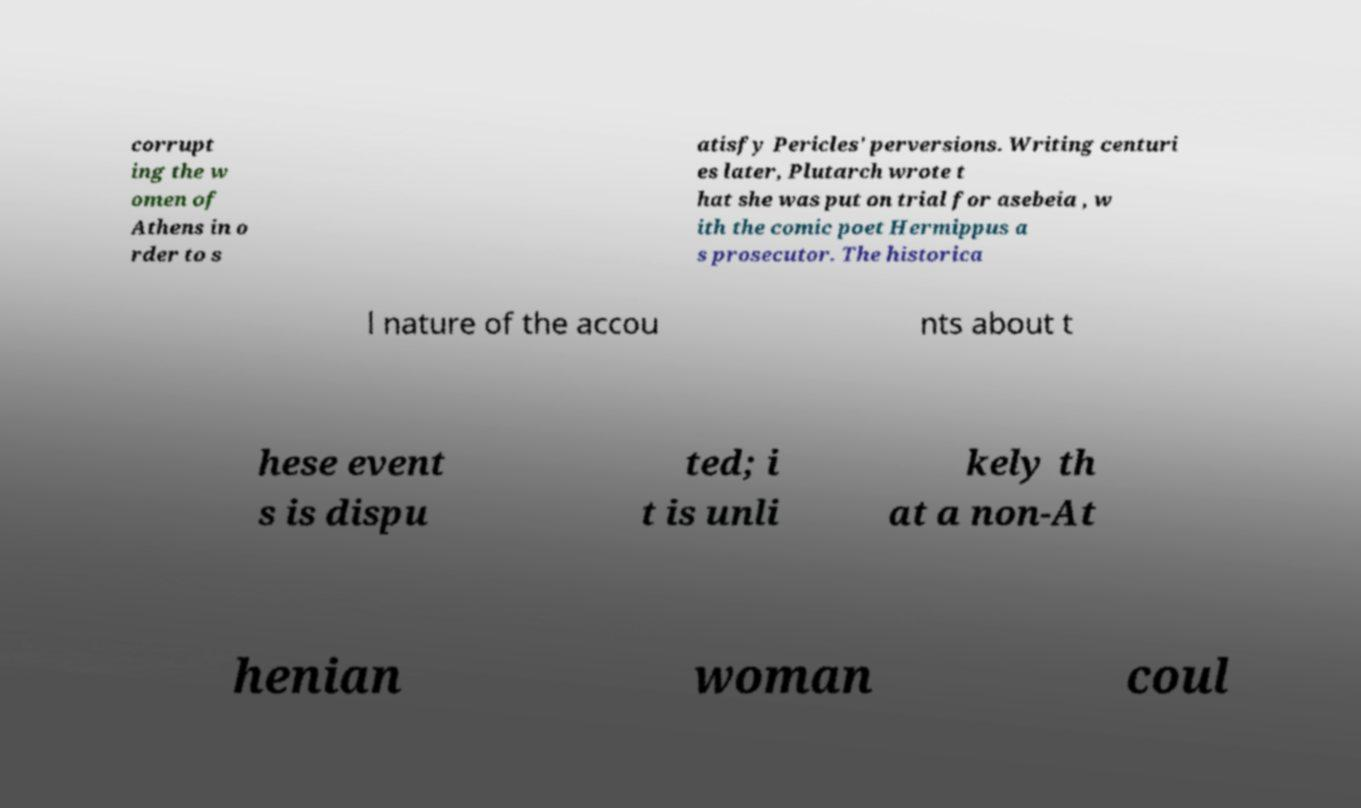I need the written content from this picture converted into text. Can you do that? corrupt ing the w omen of Athens in o rder to s atisfy Pericles' perversions. Writing centuri es later, Plutarch wrote t hat she was put on trial for asebeia , w ith the comic poet Hermippus a s prosecutor. The historica l nature of the accou nts about t hese event s is dispu ted; i t is unli kely th at a non-At henian woman coul 